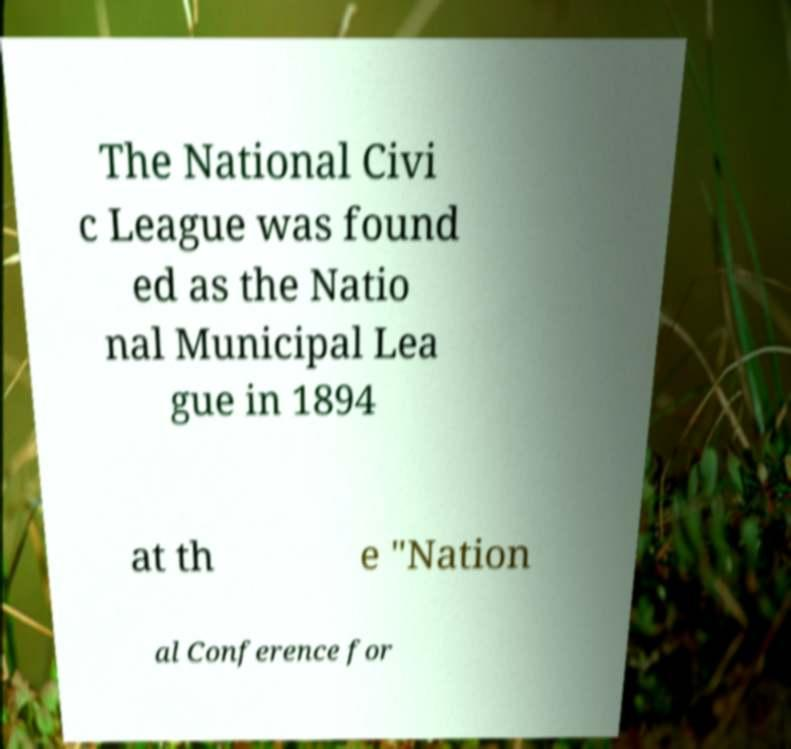For documentation purposes, I need the text within this image transcribed. Could you provide that? The National Civi c League was found ed as the Natio nal Municipal Lea gue in 1894 at th e "Nation al Conference for 